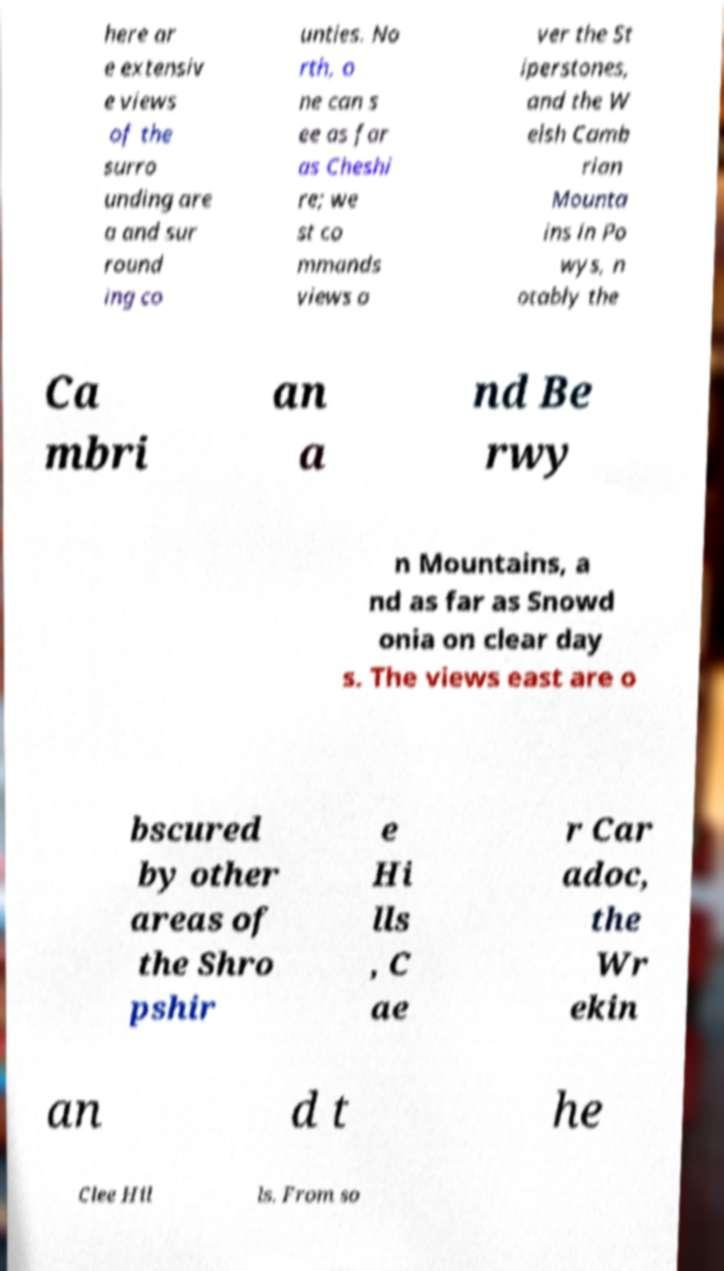Could you assist in decoding the text presented in this image and type it out clearly? here ar e extensiv e views of the surro unding are a and sur round ing co unties. No rth, o ne can s ee as far as Cheshi re; we st co mmands views o ver the St iperstones, and the W elsh Camb rian Mounta ins in Po wys, n otably the Ca mbri an a nd Be rwy n Mountains, a nd as far as Snowd onia on clear day s. The views east are o bscured by other areas of the Shro pshir e Hi lls , C ae r Car adoc, the Wr ekin an d t he Clee Hil ls. From so 